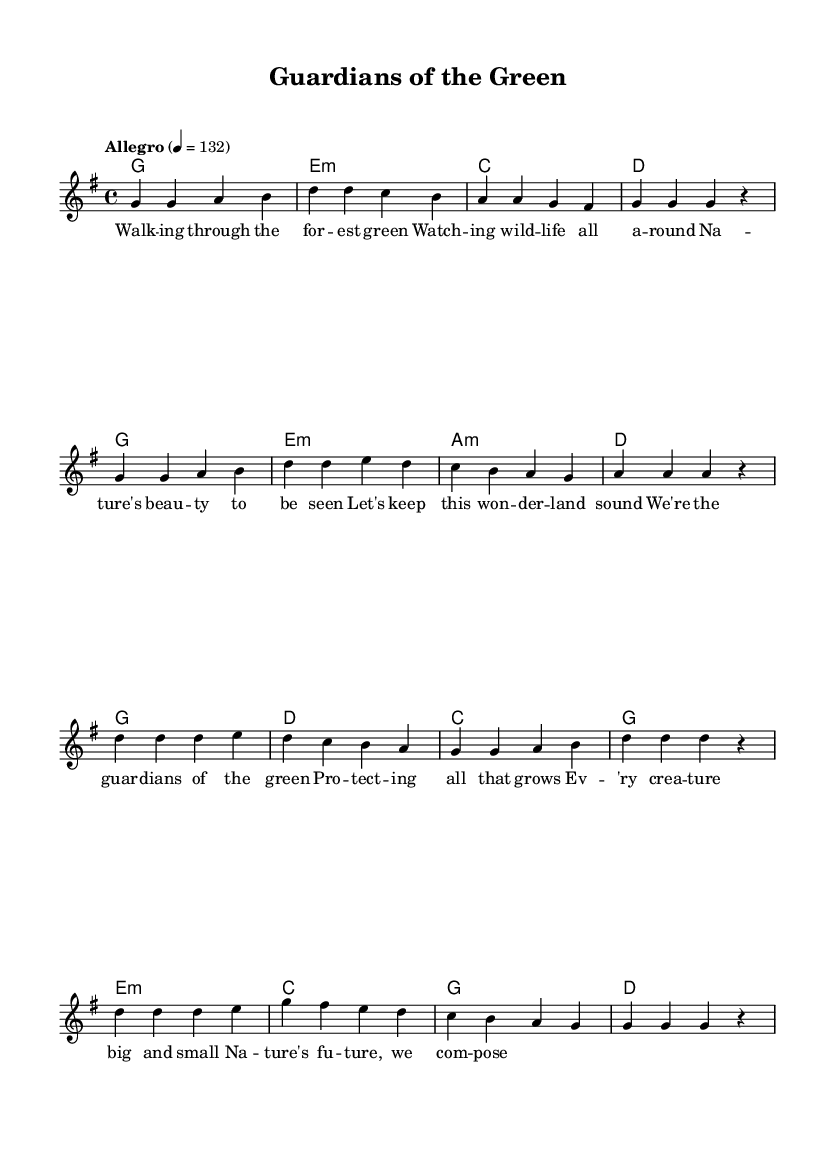What is the key signature of this music? The key signature is G major, which has one sharp (F#).
Answer: G major What is the time signature of the piece? The time signature is shown as 4/4, meaning there are four beats per measure.
Answer: 4/4 What is the tempo marking of this piece? The tempo is indicated as "Allegro" at a speed of 132 beats per minute.
Answer: Allegro, 132 How many measures are in the verse section? The verse consists of 8 measures, as counted from the provided melody section.
Answer: 8 What is the first chord of the chorus? The first chord in the chorus section is G major, which can be identified at the start of the chorus.
Answer: G Which musical phrase represents the concept of wildlife protection? The lyrics in the chorus represent wildlife protection, specifically mentioning "We're the guardians of the green".
Answer: "We're the guardians of the green" How many distinct notes are in the melody for the verse? The distinct notes can be counted directly, leading to a total of 8 unique notes identified in the verse melody.
Answer: 8 